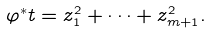Convert formula to latex. <formula><loc_0><loc_0><loc_500><loc_500>\varphi ^ { * } t = z _ { 1 } ^ { 2 } + \cdots + z _ { m + 1 } ^ { 2 } .</formula> 